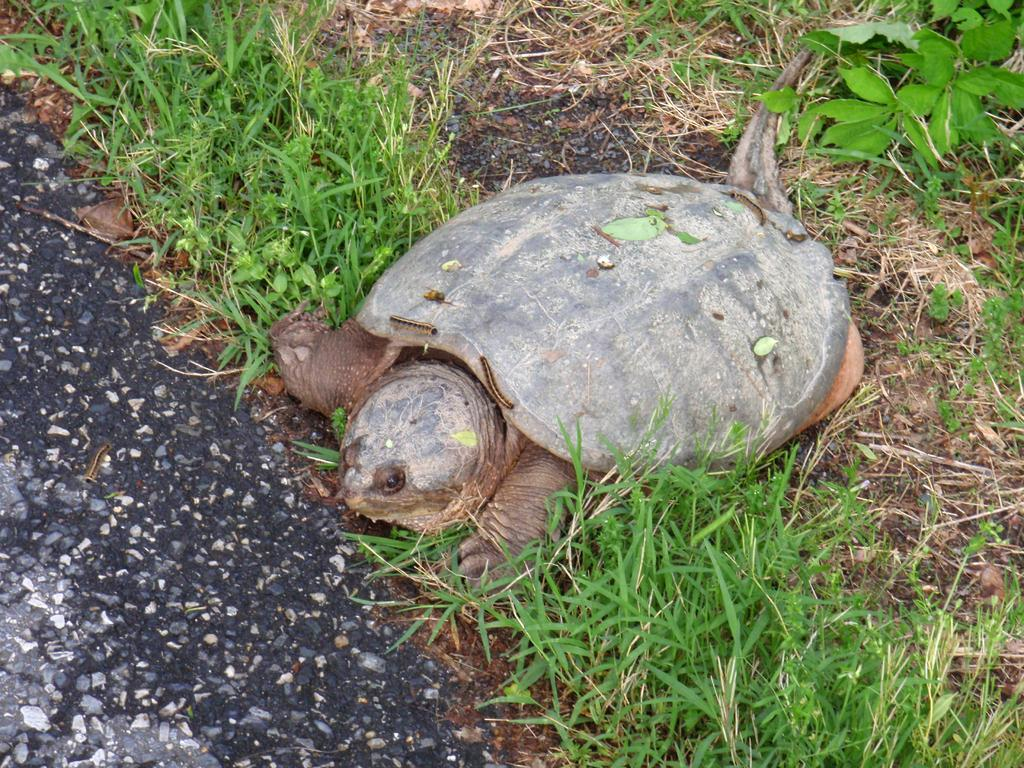What animal is present in the image? There is a tortoise in the image. Where is the tortoise located? The tortoise is on the ground. What type of surface is the tortoise on? The ground is covered with grass. What type of badge can be seen on the tortoise in the image? There is no badge present on the tortoise in the image. Is the tortoise in a cave in the image? There is no cave present in the image; the tortoise is on the grass-covered ground. 